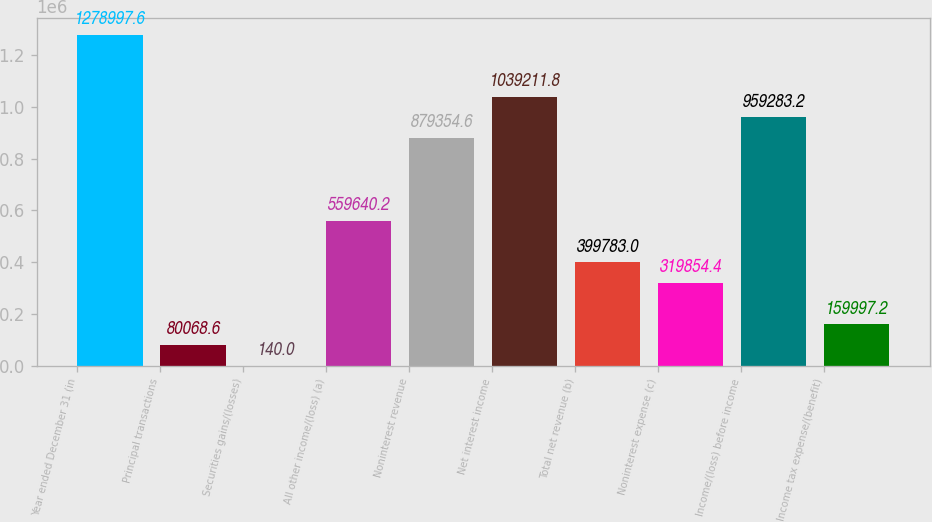Convert chart to OTSL. <chart><loc_0><loc_0><loc_500><loc_500><bar_chart><fcel>Year ended December 31 (in<fcel>Principal transactions<fcel>Securities gains/(losses)<fcel>All other income/(loss) (a)<fcel>Noninterest revenue<fcel>Net interest income<fcel>Total net revenue (b)<fcel>Noninterest expense (c)<fcel>Income/(loss) before income<fcel>Income tax expense/(benefit)<nl><fcel>1.279e+06<fcel>80068.6<fcel>140<fcel>559640<fcel>879355<fcel>1.03921e+06<fcel>399783<fcel>319854<fcel>959283<fcel>159997<nl></chart> 